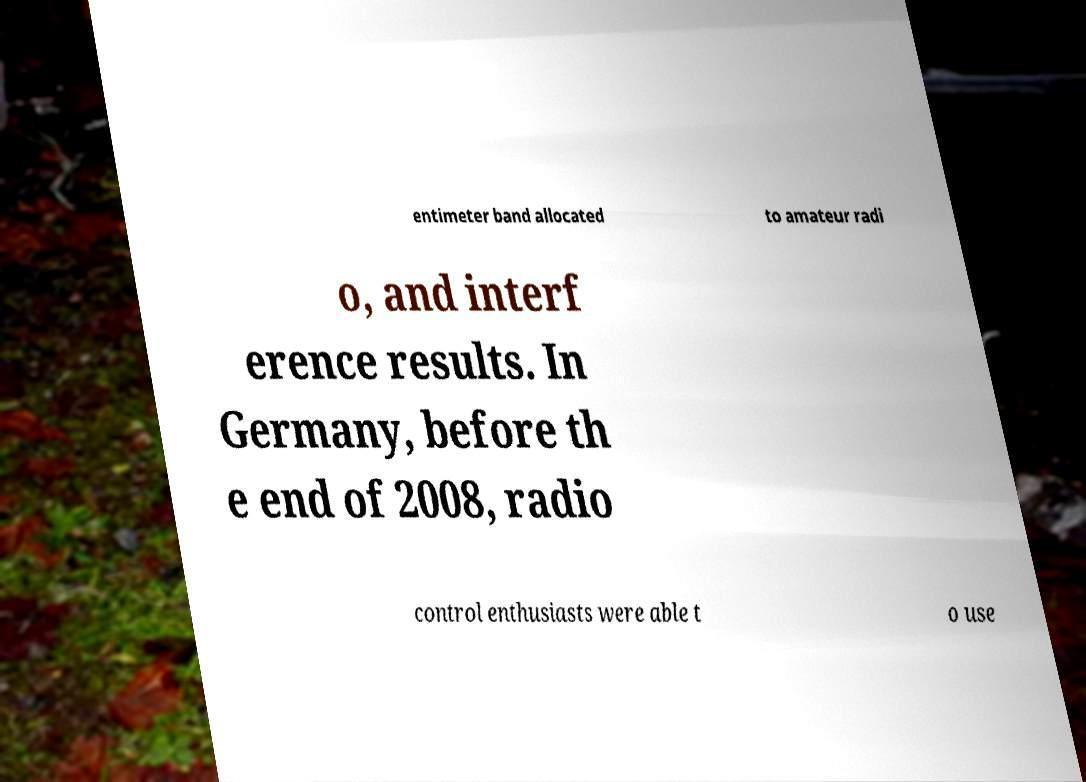Can you accurately transcribe the text from the provided image for me? entimeter band allocated to amateur radi o, and interf erence results. In Germany, before th e end of 2008, radio control enthusiasts were able t o use 